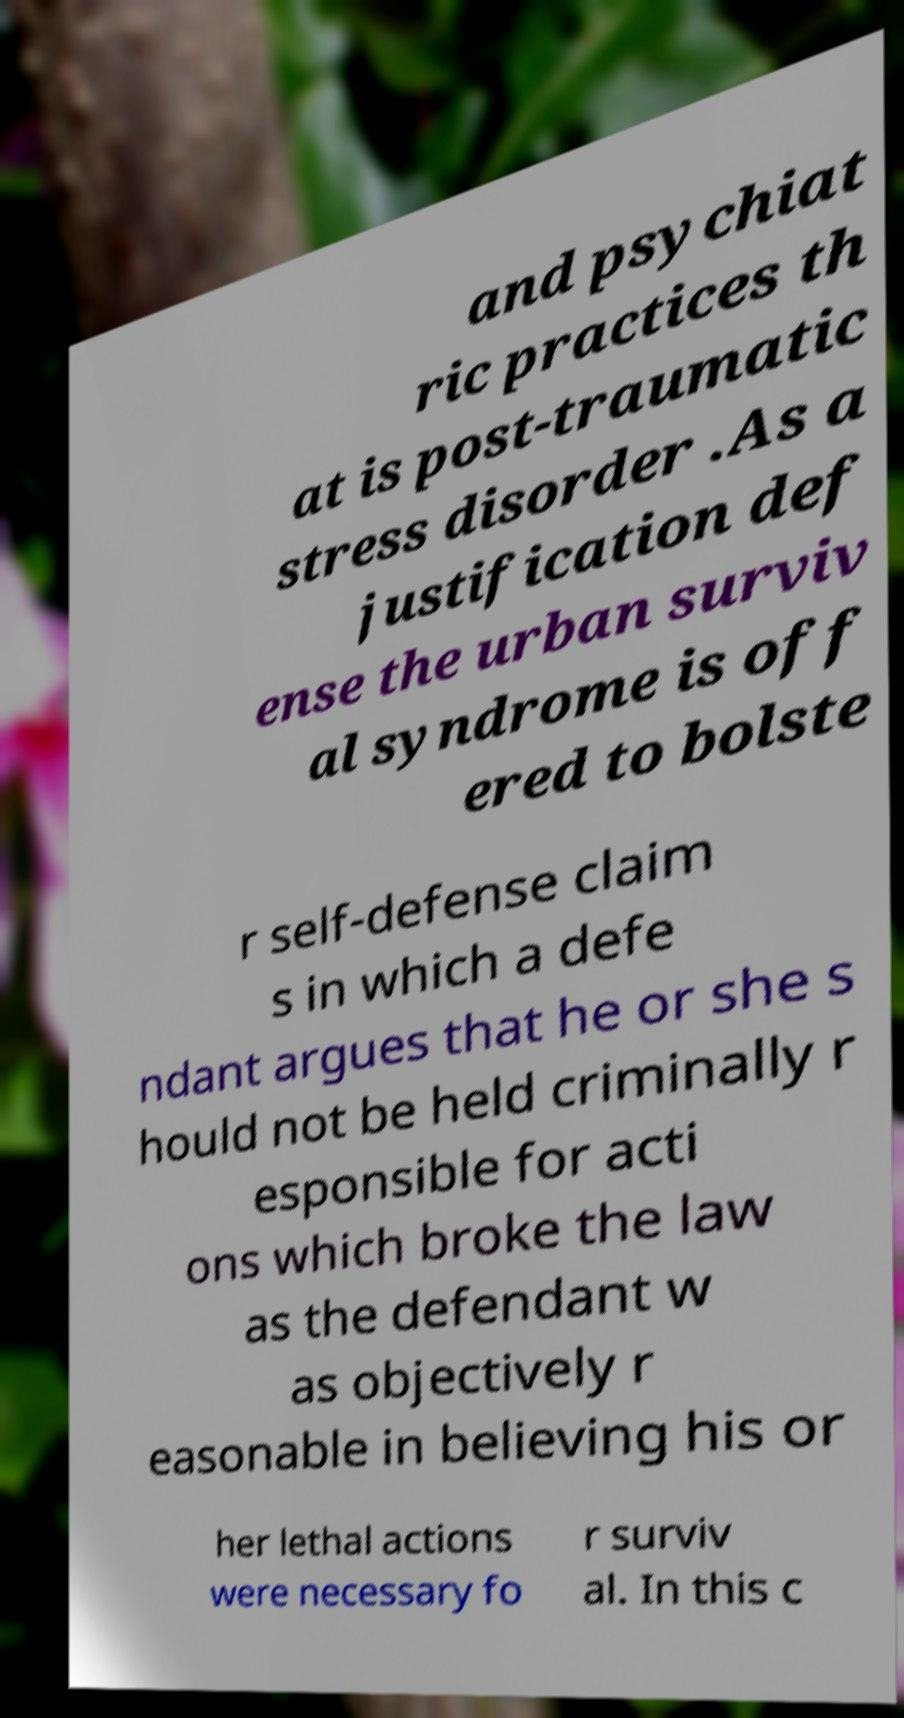Can you accurately transcribe the text from the provided image for me? and psychiat ric practices th at is post-traumatic stress disorder .As a justification def ense the urban surviv al syndrome is off ered to bolste r self-defense claim s in which a defe ndant argues that he or she s hould not be held criminally r esponsible for acti ons which broke the law as the defendant w as objectively r easonable in believing his or her lethal actions were necessary fo r surviv al. In this c 